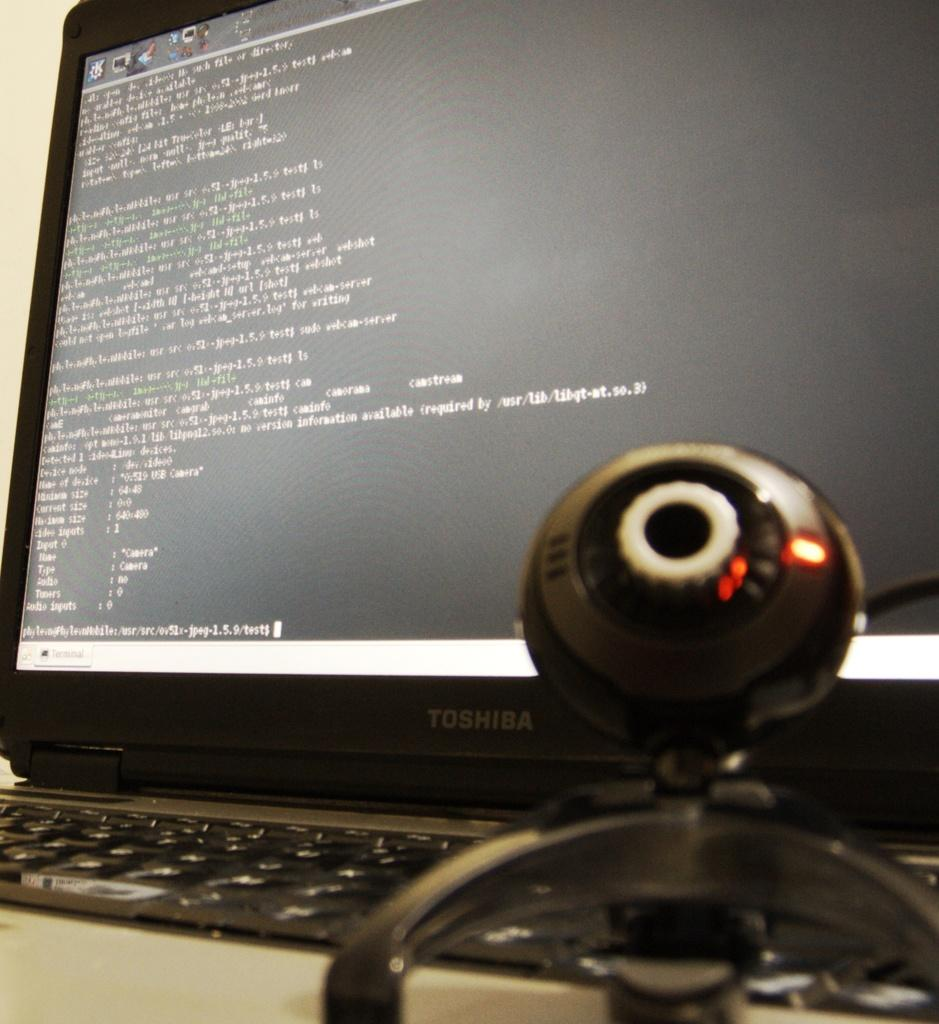Provide a one-sentence caption for the provided image. The black computer monitor being used here is a Toshiba. 